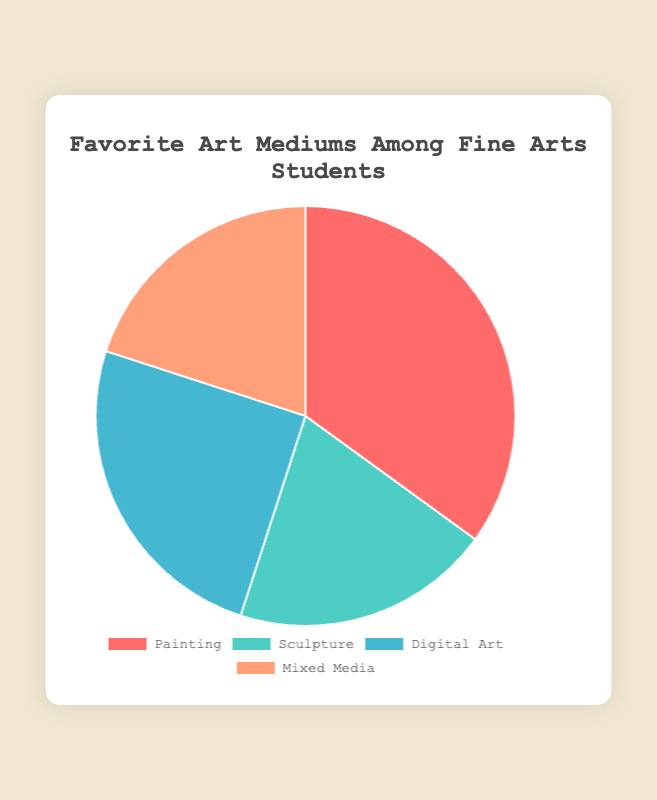What is the most popular art medium among Fine Arts students? The pie chart shows that the medium with the highest percentage is Painting, which takes up 35% of the chart.
Answer: Painting Which art mediums have an equal percentage among Fine Arts students? According to the pie chart, Sculpture and Mixed Media each have a percentage of 20%.
Answer: Sculpture and Mixed Media What is the percentage difference between Painting and Digital Art? Painting has a percentage of 35% and Digital Art has 25%. The difference is calculated as 35 - 25 = 10%.
Answer: 10% How do the percentages of Sculpture and Digital Art compare? The pie chart shows Sculpture at 20% and Digital Art at 25%. Therefore, Digital Art has a higher percentage by 5%.
Answer: Digital Art is higher by 5% What percentage of Fine Arts students prefer either Sculpture or Mixed Media? The pie chart indicates that Sculpture has 20% and Mixed Media also has 20%. Summing these percentages gives 20 + 20 = 40%.
Answer: 40% What is the combined preference percentage for Painting and Digital Art? Painting is 35% and Digital Art is 25%. Adding these gives 35 + 25 = 60%.
Answer: 60% Which medium represents the smallest segment on the pie chart, and what color is it? Both Sculpture and Mixed Media represent the smallest segments at 20% each. Sculpture is represented with a turquoise color and Mixed Media with a peach color.
Answer: Sculpture and Mixed Media; Turquoise and Peach If we were to combine the preferences for Digital Art and Mixed Media, how would this compare to the preference for Painting? Combined, Digital Art and Mixed Media make up 25% + 20% = 45%. Painting is at 35%, so the combined percentage is 10% higher than Painting.
Answer: 45%, 10% higher What is the average percentage preference for all art mediums depicted in the pie chart? The sum of the percentages is 35 (Painting) + 20 (Sculpture) + 25 (Digital Art) + 20 (Mixed Media) = 100. The average is then 100 / 4 = 25%.
Answer: 25% Which medium has the largest visual segment on the pie chart, and how much larger is it compared to the smallest segment? Painting has the largest segment at 35%, while the smallest is Sculpture and Mixed Media at 20%. The difference is 35 - 20 = 15%.
Answer: Painting, 15% larger 